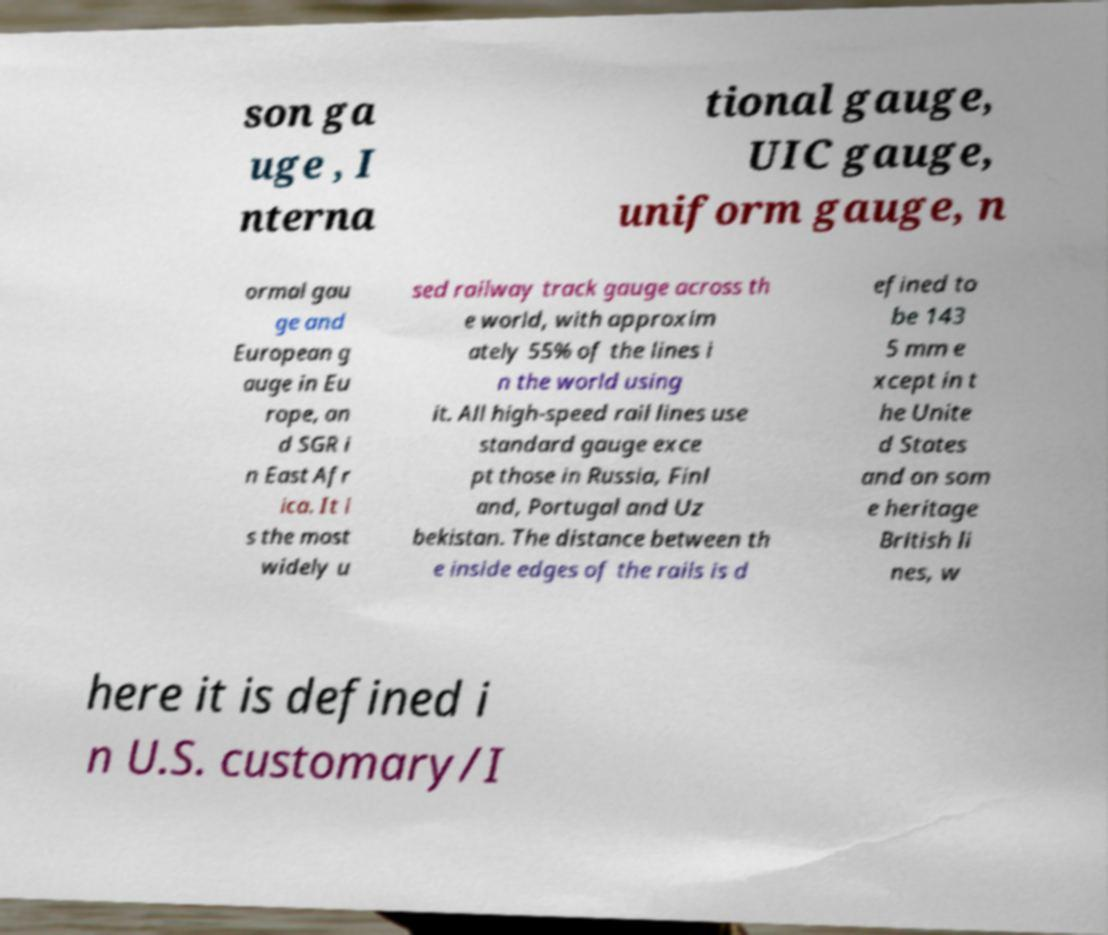Please identify and transcribe the text found in this image. son ga uge , I nterna tional gauge, UIC gauge, uniform gauge, n ormal gau ge and European g auge in Eu rope, an d SGR i n East Afr ica. It i s the most widely u sed railway track gauge across th e world, with approxim ately 55% of the lines i n the world using it. All high-speed rail lines use standard gauge exce pt those in Russia, Finl and, Portugal and Uz bekistan. The distance between th e inside edges of the rails is d efined to be 143 5 mm e xcept in t he Unite d States and on som e heritage British li nes, w here it is defined i n U.S. customary/I 